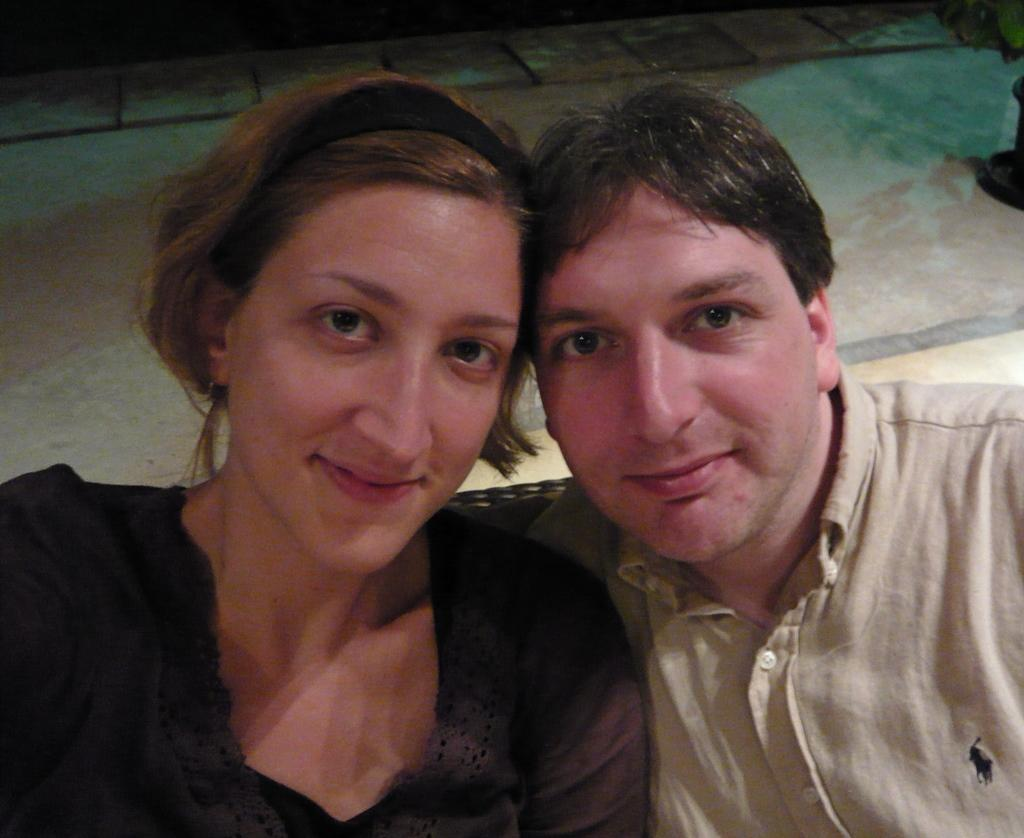Who are the people in the image? There is a man and a woman in the image. What can be seen in the background of the image? There is a floor visible in the background of the image. What songs are the man and woman singing in the image? There is no indication in the image that the man and woman are singing, so it cannot be determined from the picture. 